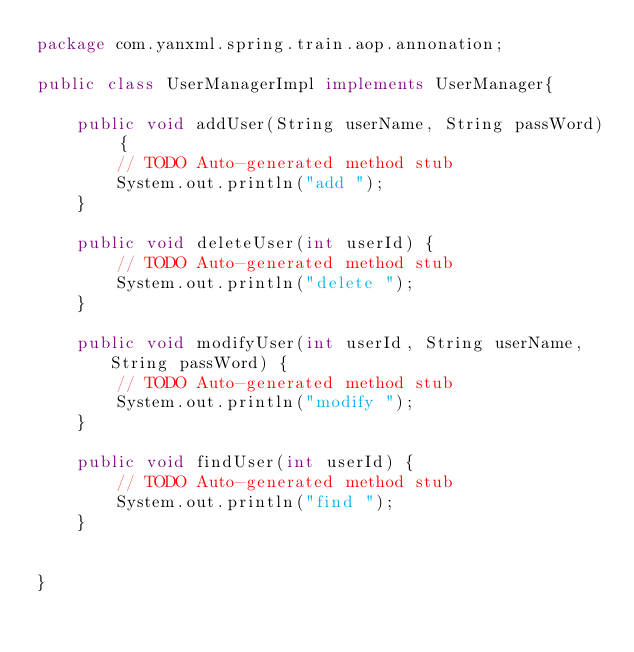<code> <loc_0><loc_0><loc_500><loc_500><_Java_>package com.yanxml.spring.train.aop.annonation;

public class UserManagerImpl implements UserManager{

	public void addUser(String userName, String passWord) {
		// TODO Auto-generated method stub
		System.out.println("add ");
	}

	public void deleteUser(int userId) {
		// TODO Auto-generated method stub
		System.out.println("delete ");
	}

	public void modifyUser(int userId, String userName, String passWord) {
		// TODO Auto-generated method stub
		System.out.println("modify ");
	}

	public void findUser(int userId) {
		// TODO Auto-generated method stub
		System.out.println("find ");
	}
	

}
</code> 